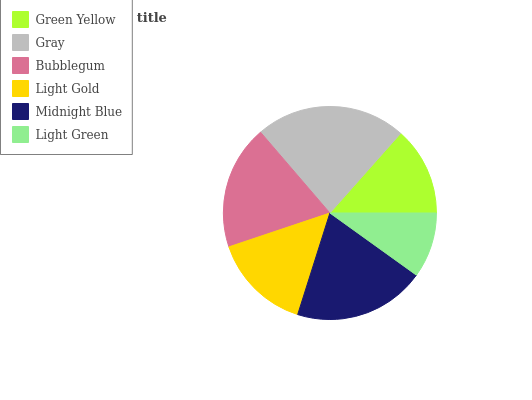Is Light Green the minimum?
Answer yes or no. Yes. Is Gray the maximum?
Answer yes or no. Yes. Is Bubblegum the minimum?
Answer yes or no. No. Is Bubblegum the maximum?
Answer yes or no. No. Is Gray greater than Bubblegum?
Answer yes or no. Yes. Is Bubblegum less than Gray?
Answer yes or no. Yes. Is Bubblegum greater than Gray?
Answer yes or no. No. Is Gray less than Bubblegum?
Answer yes or no. No. Is Bubblegum the high median?
Answer yes or no. Yes. Is Light Gold the low median?
Answer yes or no. Yes. Is Midnight Blue the high median?
Answer yes or no. No. Is Gray the low median?
Answer yes or no. No. 